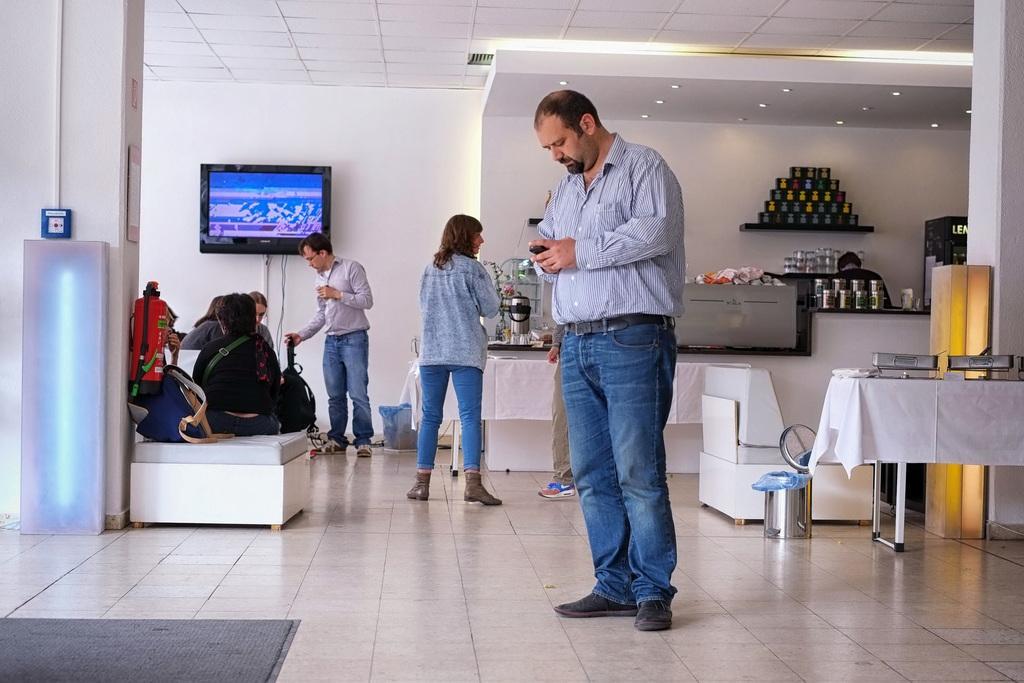How would you summarize this image in a sentence or two? This picture consists of inside view of a room and in the room I can see there are few persons standing on the floor , on the right side I can see a table and I can see a white color cloth and I can see a cup glass kept on the rack in the middle. In the middle I can see sofa set and bag and cylinder and I can see screen. 